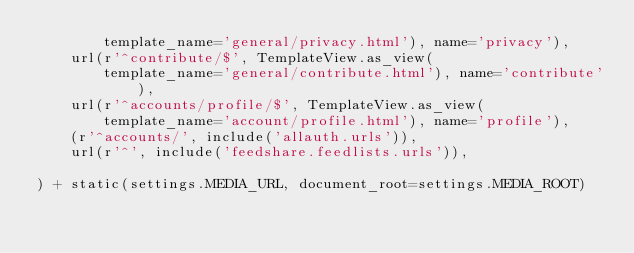<code> <loc_0><loc_0><loc_500><loc_500><_Python_>        template_name='general/privacy.html'), name='privacy'),
    url(r'^contribute/$', TemplateView.as_view(
        template_name='general/contribute.html'), name='contribute'),
    url(r'^accounts/profile/$', TemplateView.as_view(
        template_name='account/profile.html'), name='profile'),
    (r'^accounts/', include('allauth.urls')),
    url(r'^', include('feedshare.feedlists.urls')),

) + static(settings.MEDIA_URL, document_root=settings.MEDIA_ROOT)
</code> 